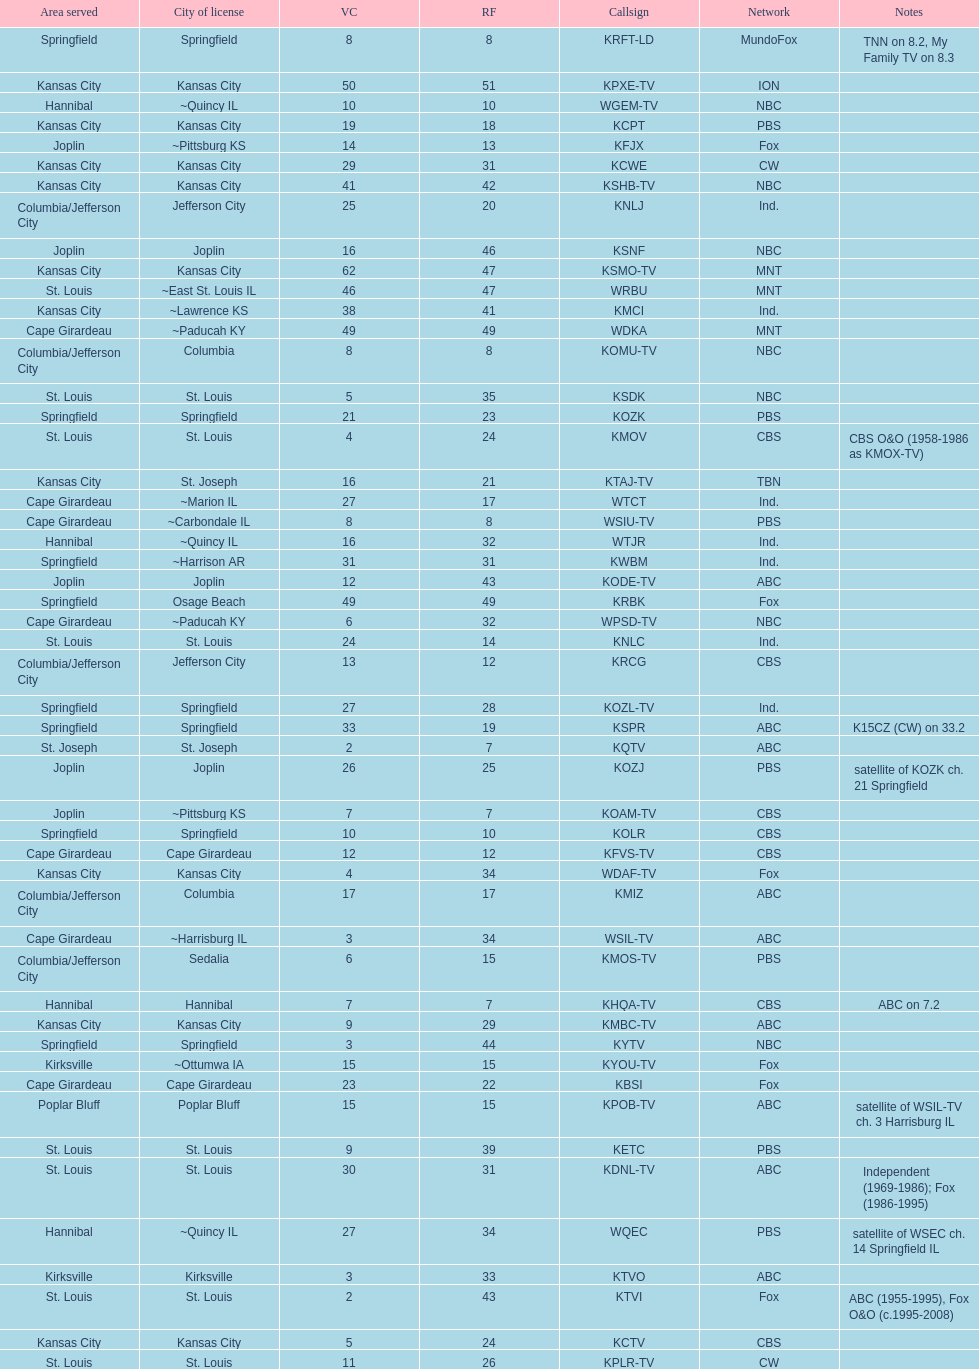How many areas have at least 5 stations? 6. 